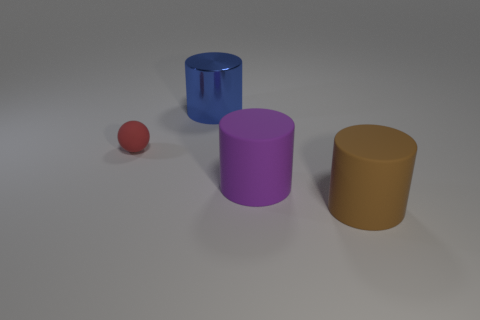Is there anything else that is made of the same material as the blue cylinder?
Keep it short and to the point. No. There is another rubber object that is the same shape as the purple rubber thing; what is its color?
Give a very brief answer. Brown. Do the thing to the left of the metal thing and the big cylinder behind the small matte sphere have the same material?
Offer a terse response. No. There is a matte thing that is behind the brown rubber cylinder and to the right of the small red sphere; what is its shape?
Provide a short and direct response. Cylinder. How many shiny things are there?
Make the answer very short. 1. There is a blue object that is the same shape as the brown object; what size is it?
Keep it short and to the point. Large. Does the large object that is behind the red rubber ball have the same shape as the large purple thing?
Offer a very short reply. Yes. What is the color of the big rubber thing that is on the left side of the brown matte cylinder?
Provide a short and direct response. Purple. How many other things are the same size as the purple matte thing?
Make the answer very short. 2. Is there any other thing that is the same shape as the small matte thing?
Provide a short and direct response. No. 